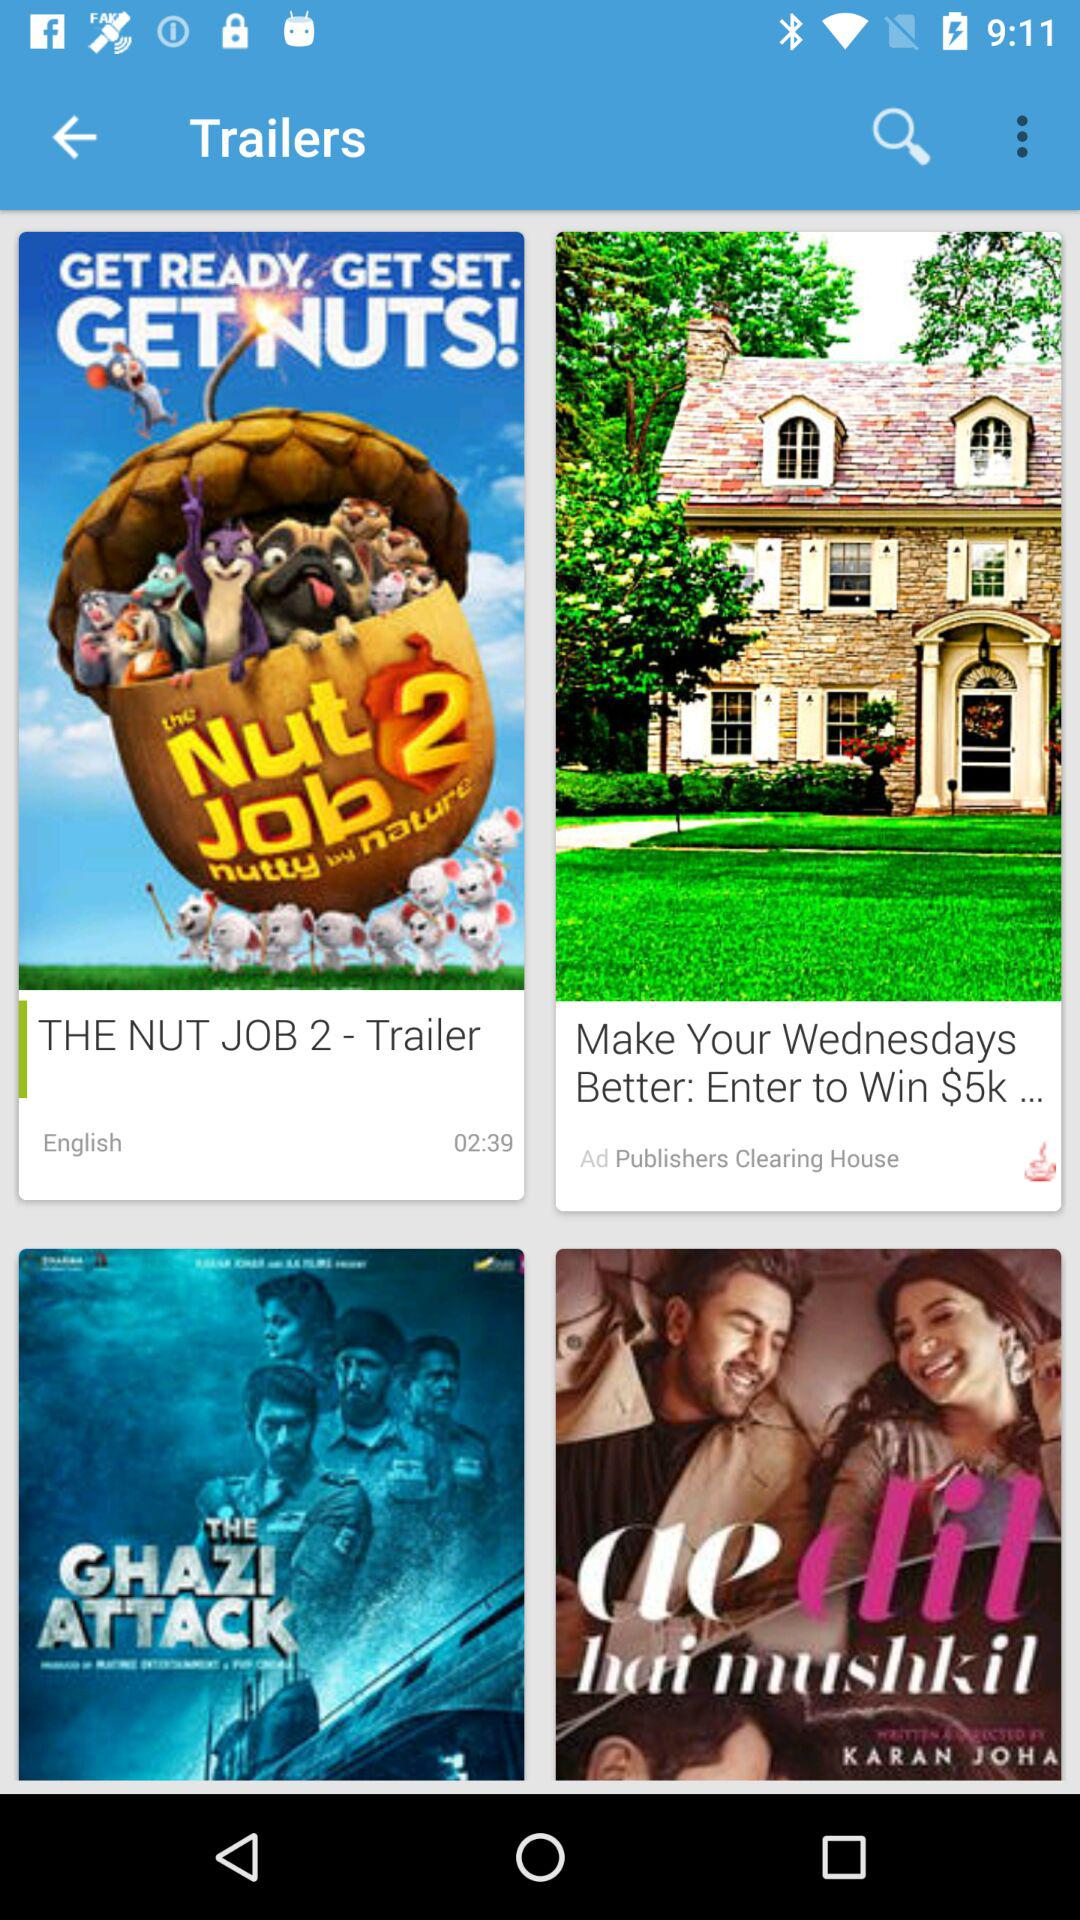How long is "The Nut Job 2" trailer? The trailer is 2 minutes and 39 seconds long. 